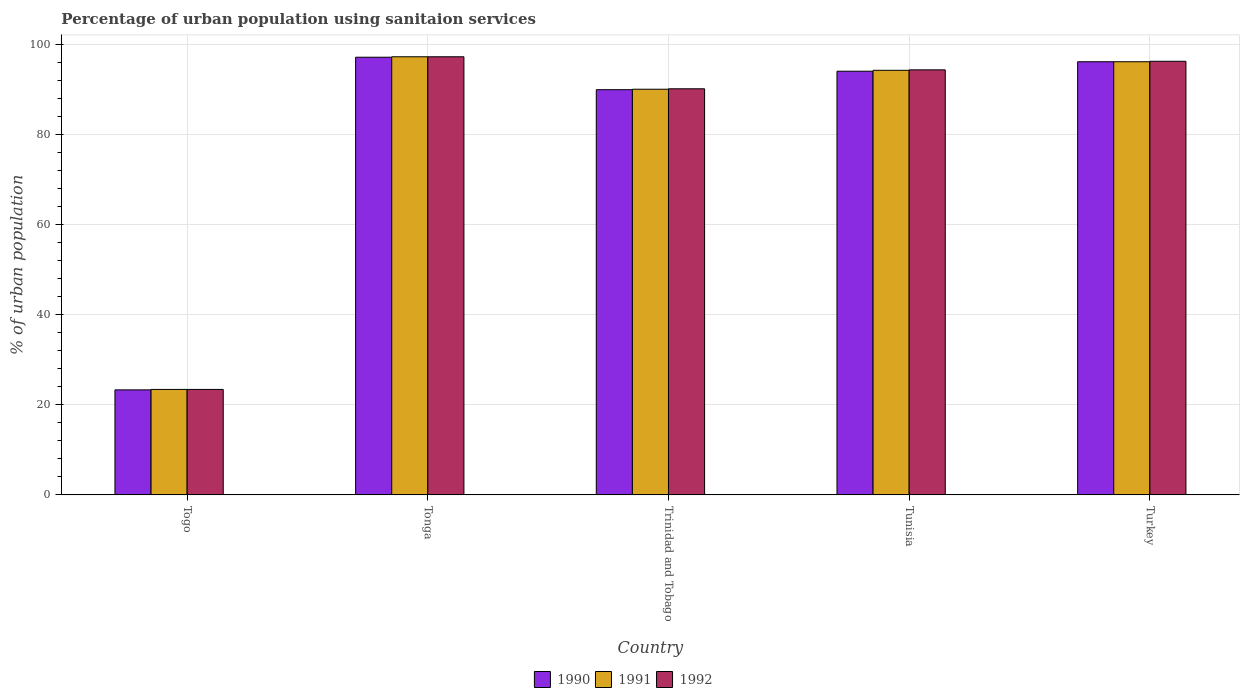How many different coloured bars are there?
Provide a succinct answer. 3. How many groups of bars are there?
Ensure brevity in your answer.  5. Are the number of bars on each tick of the X-axis equal?
Provide a succinct answer. Yes. How many bars are there on the 5th tick from the right?
Offer a very short reply. 3. What is the label of the 1st group of bars from the left?
Your response must be concise. Togo. What is the percentage of urban population using sanitaion services in 1990 in Tunisia?
Provide a short and direct response. 94. Across all countries, what is the maximum percentage of urban population using sanitaion services in 1990?
Make the answer very short. 97.1. Across all countries, what is the minimum percentage of urban population using sanitaion services in 1991?
Your answer should be compact. 23.4. In which country was the percentage of urban population using sanitaion services in 1990 maximum?
Keep it short and to the point. Tonga. In which country was the percentage of urban population using sanitaion services in 1990 minimum?
Provide a succinct answer. Togo. What is the total percentage of urban population using sanitaion services in 1991 in the graph?
Your answer should be very brief. 400.9. What is the difference between the percentage of urban population using sanitaion services in 1990 in Togo and that in Trinidad and Tobago?
Keep it short and to the point. -66.6. What is the difference between the percentage of urban population using sanitaion services in 1990 in Tunisia and the percentage of urban population using sanitaion services in 1992 in Trinidad and Tobago?
Give a very brief answer. 3.9. What is the average percentage of urban population using sanitaion services in 1990 per country?
Offer a very short reply. 80.08. What is the difference between the percentage of urban population using sanitaion services of/in 1992 and percentage of urban population using sanitaion services of/in 1991 in Turkey?
Ensure brevity in your answer.  0.1. In how many countries, is the percentage of urban population using sanitaion services in 1990 greater than 44 %?
Give a very brief answer. 4. What is the ratio of the percentage of urban population using sanitaion services in 1990 in Tunisia to that in Turkey?
Offer a very short reply. 0.98. Is the percentage of urban population using sanitaion services in 1992 in Togo less than that in Turkey?
Ensure brevity in your answer.  Yes. What is the difference between the highest and the second highest percentage of urban population using sanitaion services in 1990?
Keep it short and to the point. -1. What is the difference between the highest and the lowest percentage of urban population using sanitaion services in 1991?
Keep it short and to the point. 73.8. In how many countries, is the percentage of urban population using sanitaion services in 1992 greater than the average percentage of urban population using sanitaion services in 1992 taken over all countries?
Keep it short and to the point. 4. Is the sum of the percentage of urban population using sanitaion services in 1991 in Trinidad and Tobago and Tunisia greater than the maximum percentage of urban population using sanitaion services in 1990 across all countries?
Your answer should be compact. Yes. What does the 3rd bar from the left in Trinidad and Tobago represents?
Ensure brevity in your answer.  1992. What does the 1st bar from the right in Togo represents?
Your answer should be very brief. 1992. How many bars are there?
Give a very brief answer. 15. Are all the bars in the graph horizontal?
Make the answer very short. No. How many countries are there in the graph?
Your answer should be compact. 5. Are the values on the major ticks of Y-axis written in scientific E-notation?
Your answer should be very brief. No. Does the graph contain grids?
Provide a short and direct response. Yes. How many legend labels are there?
Keep it short and to the point. 3. What is the title of the graph?
Give a very brief answer. Percentage of urban population using sanitaion services. Does "1960" appear as one of the legend labels in the graph?
Offer a very short reply. No. What is the label or title of the Y-axis?
Offer a terse response. % of urban population. What is the % of urban population of 1990 in Togo?
Provide a succinct answer. 23.3. What is the % of urban population of 1991 in Togo?
Offer a terse response. 23.4. What is the % of urban population in 1992 in Togo?
Your answer should be very brief. 23.4. What is the % of urban population in 1990 in Tonga?
Offer a very short reply. 97.1. What is the % of urban population of 1991 in Tonga?
Make the answer very short. 97.2. What is the % of urban population of 1992 in Tonga?
Provide a short and direct response. 97.2. What is the % of urban population in 1990 in Trinidad and Tobago?
Ensure brevity in your answer.  89.9. What is the % of urban population in 1991 in Trinidad and Tobago?
Make the answer very short. 90. What is the % of urban population in 1992 in Trinidad and Tobago?
Your answer should be compact. 90.1. What is the % of urban population in 1990 in Tunisia?
Your answer should be very brief. 94. What is the % of urban population in 1991 in Tunisia?
Provide a short and direct response. 94.2. What is the % of urban population of 1992 in Tunisia?
Offer a very short reply. 94.3. What is the % of urban population of 1990 in Turkey?
Ensure brevity in your answer.  96.1. What is the % of urban population of 1991 in Turkey?
Your answer should be very brief. 96.1. What is the % of urban population in 1992 in Turkey?
Give a very brief answer. 96.2. Across all countries, what is the maximum % of urban population of 1990?
Provide a succinct answer. 97.1. Across all countries, what is the maximum % of urban population in 1991?
Provide a succinct answer. 97.2. Across all countries, what is the maximum % of urban population in 1992?
Your answer should be very brief. 97.2. Across all countries, what is the minimum % of urban population of 1990?
Your answer should be compact. 23.3. Across all countries, what is the minimum % of urban population of 1991?
Your response must be concise. 23.4. Across all countries, what is the minimum % of urban population in 1992?
Your answer should be compact. 23.4. What is the total % of urban population in 1990 in the graph?
Keep it short and to the point. 400.4. What is the total % of urban population of 1991 in the graph?
Offer a very short reply. 400.9. What is the total % of urban population of 1992 in the graph?
Give a very brief answer. 401.2. What is the difference between the % of urban population in 1990 in Togo and that in Tonga?
Your answer should be compact. -73.8. What is the difference between the % of urban population of 1991 in Togo and that in Tonga?
Your answer should be very brief. -73.8. What is the difference between the % of urban population of 1992 in Togo and that in Tonga?
Ensure brevity in your answer.  -73.8. What is the difference between the % of urban population of 1990 in Togo and that in Trinidad and Tobago?
Your answer should be very brief. -66.6. What is the difference between the % of urban population in 1991 in Togo and that in Trinidad and Tobago?
Provide a succinct answer. -66.6. What is the difference between the % of urban population in 1992 in Togo and that in Trinidad and Tobago?
Your answer should be very brief. -66.7. What is the difference between the % of urban population in 1990 in Togo and that in Tunisia?
Your answer should be very brief. -70.7. What is the difference between the % of urban population in 1991 in Togo and that in Tunisia?
Offer a very short reply. -70.8. What is the difference between the % of urban population in 1992 in Togo and that in Tunisia?
Provide a succinct answer. -70.9. What is the difference between the % of urban population of 1990 in Togo and that in Turkey?
Give a very brief answer. -72.8. What is the difference between the % of urban population in 1991 in Togo and that in Turkey?
Keep it short and to the point. -72.7. What is the difference between the % of urban population of 1992 in Togo and that in Turkey?
Ensure brevity in your answer.  -72.8. What is the difference between the % of urban population in 1990 in Tonga and that in Trinidad and Tobago?
Your answer should be very brief. 7.2. What is the difference between the % of urban population of 1991 in Tonga and that in Trinidad and Tobago?
Offer a terse response. 7.2. What is the difference between the % of urban population of 1991 in Tonga and that in Tunisia?
Provide a succinct answer. 3. What is the difference between the % of urban population of 1992 in Tonga and that in Tunisia?
Make the answer very short. 2.9. What is the difference between the % of urban population in 1990 in Tonga and that in Turkey?
Keep it short and to the point. 1. What is the difference between the % of urban population of 1992 in Tonga and that in Turkey?
Ensure brevity in your answer.  1. What is the difference between the % of urban population in 1991 in Trinidad and Tobago and that in Tunisia?
Your response must be concise. -4.2. What is the difference between the % of urban population of 1990 in Trinidad and Tobago and that in Turkey?
Make the answer very short. -6.2. What is the difference between the % of urban population in 1991 in Trinidad and Tobago and that in Turkey?
Your answer should be compact. -6.1. What is the difference between the % of urban population of 1990 in Tunisia and that in Turkey?
Offer a very short reply. -2.1. What is the difference between the % of urban population of 1991 in Tunisia and that in Turkey?
Offer a very short reply. -1.9. What is the difference between the % of urban population of 1992 in Tunisia and that in Turkey?
Provide a succinct answer. -1.9. What is the difference between the % of urban population in 1990 in Togo and the % of urban population in 1991 in Tonga?
Provide a short and direct response. -73.9. What is the difference between the % of urban population of 1990 in Togo and the % of urban population of 1992 in Tonga?
Your answer should be compact. -73.9. What is the difference between the % of urban population of 1991 in Togo and the % of urban population of 1992 in Tonga?
Provide a succinct answer. -73.8. What is the difference between the % of urban population of 1990 in Togo and the % of urban population of 1991 in Trinidad and Tobago?
Give a very brief answer. -66.7. What is the difference between the % of urban population in 1990 in Togo and the % of urban population in 1992 in Trinidad and Tobago?
Provide a short and direct response. -66.8. What is the difference between the % of urban population of 1991 in Togo and the % of urban population of 1992 in Trinidad and Tobago?
Your answer should be very brief. -66.7. What is the difference between the % of urban population in 1990 in Togo and the % of urban population in 1991 in Tunisia?
Give a very brief answer. -70.9. What is the difference between the % of urban population in 1990 in Togo and the % of urban population in 1992 in Tunisia?
Your answer should be very brief. -71. What is the difference between the % of urban population of 1991 in Togo and the % of urban population of 1992 in Tunisia?
Keep it short and to the point. -70.9. What is the difference between the % of urban population in 1990 in Togo and the % of urban population in 1991 in Turkey?
Keep it short and to the point. -72.8. What is the difference between the % of urban population in 1990 in Togo and the % of urban population in 1992 in Turkey?
Make the answer very short. -72.9. What is the difference between the % of urban population of 1991 in Togo and the % of urban population of 1992 in Turkey?
Provide a short and direct response. -72.8. What is the difference between the % of urban population in 1990 in Tonga and the % of urban population in 1991 in Tunisia?
Make the answer very short. 2.9. What is the difference between the % of urban population in 1991 in Tonga and the % of urban population in 1992 in Tunisia?
Your answer should be very brief. 2.9. What is the difference between the % of urban population of 1991 in Tunisia and the % of urban population of 1992 in Turkey?
Keep it short and to the point. -2. What is the average % of urban population of 1990 per country?
Your response must be concise. 80.08. What is the average % of urban population of 1991 per country?
Give a very brief answer. 80.18. What is the average % of urban population in 1992 per country?
Provide a short and direct response. 80.24. What is the difference between the % of urban population of 1990 and % of urban population of 1991 in Togo?
Your answer should be compact. -0.1. What is the difference between the % of urban population in 1990 and % of urban population in 1991 in Tonga?
Your answer should be compact. -0.1. What is the difference between the % of urban population in 1990 and % of urban population in 1991 in Trinidad and Tobago?
Make the answer very short. -0.1. What is the difference between the % of urban population of 1990 and % of urban population of 1992 in Trinidad and Tobago?
Your answer should be compact. -0.2. What is the difference between the % of urban population of 1990 and % of urban population of 1991 in Turkey?
Offer a very short reply. 0. What is the ratio of the % of urban population in 1990 in Togo to that in Tonga?
Provide a succinct answer. 0.24. What is the ratio of the % of urban population in 1991 in Togo to that in Tonga?
Your response must be concise. 0.24. What is the ratio of the % of urban population in 1992 in Togo to that in Tonga?
Provide a short and direct response. 0.24. What is the ratio of the % of urban population of 1990 in Togo to that in Trinidad and Tobago?
Provide a succinct answer. 0.26. What is the ratio of the % of urban population of 1991 in Togo to that in Trinidad and Tobago?
Give a very brief answer. 0.26. What is the ratio of the % of urban population of 1992 in Togo to that in Trinidad and Tobago?
Your answer should be very brief. 0.26. What is the ratio of the % of urban population of 1990 in Togo to that in Tunisia?
Offer a terse response. 0.25. What is the ratio of the % of urban population in 1991 in Togo to that in Tunisia?
Provide a succinct answer. 0.25. What is the ratio of the % of urban population of 1992 in Togo to that in Tunisia?
Your response must be concise. 0.25. What is the ratio of the % of urban population in 1990 in Togo to that in Turkey?
Ensure brevity in your answer.  0.24. What is the ratio of the % of urban population of 1991 in Togo to that in Turkey?
Make the answer very short. 0.24. What is the ratio of the % of urban population of 1992 in Togo to that in Turkey?
Offer a very short reply. 0.24. What is the ratio of the % of urban population in 1990 in Tonga to that in Trinidad and Tobago?
Your response must be concise. 1.08. What is the ratio of the % of urban population of 1991 in Tonga to that in Trinidad and Tobago?
Your answer should be very brief. 1.08. What is the ratio of the % of urban population in 1992 in Tonga to that in Trinidad and Tobago?
Ensure brevity in your answer.  1.08. What is the ratio of the % of urban population of 1990 in Tonga to that in Tunisia?
Give a very brief answer. 1.03. What is the ratio of the % of urban population of 1991 in Tonga to that in Tunisia?
Make the answer very short. 1.03. What is the ratio of the % of urban population in 1992 in Tonga to that in Tunisia?
Ensure brevity in your answer.  1.03. What is the ratio of the % of urban population in 1990 in Tonga to that in Turkey?
Keep it short and to the point. 1.01. What is the ratio of the % of urban population of 1991 in Tonga to that in Turkey?
Your answer should be very brief. 1.01. What is the ratio of the % of urban population in 1992 in Tonga to that in Turkey?
Make the answer very short. 1.01. What is the ratio of the % of urban population in 1990 in Trinidad and Tobago to that in Tunisia?
Provide a short and direct response. 0.96. What is the ratio of the % of urban population of 1991 in Trinidad and Tobago to that in Tunisia?
Offer a terse response. 0.96. What is the ratio of the % of urban population in 1992 in Trinidad and Tobago to that in Tunisia?
Make the answer very short. 0.96. What is the ratio of the % of urban population in 1990 in Trinidad and Tobago to that in Turkey?
Your response must be concise. 0.94. What is the ratio of the % of urban population of 1991 in Trinidad and Tobago to that in Turkey?
Keep it short and to the point. 0.94. What is the ratio of the % of urban population of 1992 in Trinidad and Tobago to that in Turkey?
Offer a terse response. 0.94. What is the ratio of the % of urban population of 1990 in Tunisia to that in Turkey?
Provide a short and direct response. 0.98. What is the ratio of the % of urban population of 1991 in Tunisia to that in Turkey?
Your answer should be compact. 0.98. What is the ratio of the % of urban population of 1992 in Tunisia to that in Turkey?
Your response must be concise. 0.98. What is the difference between the highest and the second highest % of urban population in 1990?
Make the answer very short. 1. What is the difference between the highest and the second highest % of urban population in 1991?
Your response must be concise. 1.1. What is the difference between the highest and the second highest % of urban population of 1992?
Ensure brevity in your answer.  1. What is the difference between the highest and the lowest % of urban population in 1990?
Offer a terse response. 73.8. What is the difference between the highest and the lowest % of urban population of 1991?
Offer a very short reply. 73.8. What is the difference between the highest and the lowest % of urban population in 1992?
Your response must be concise. 73.8. 